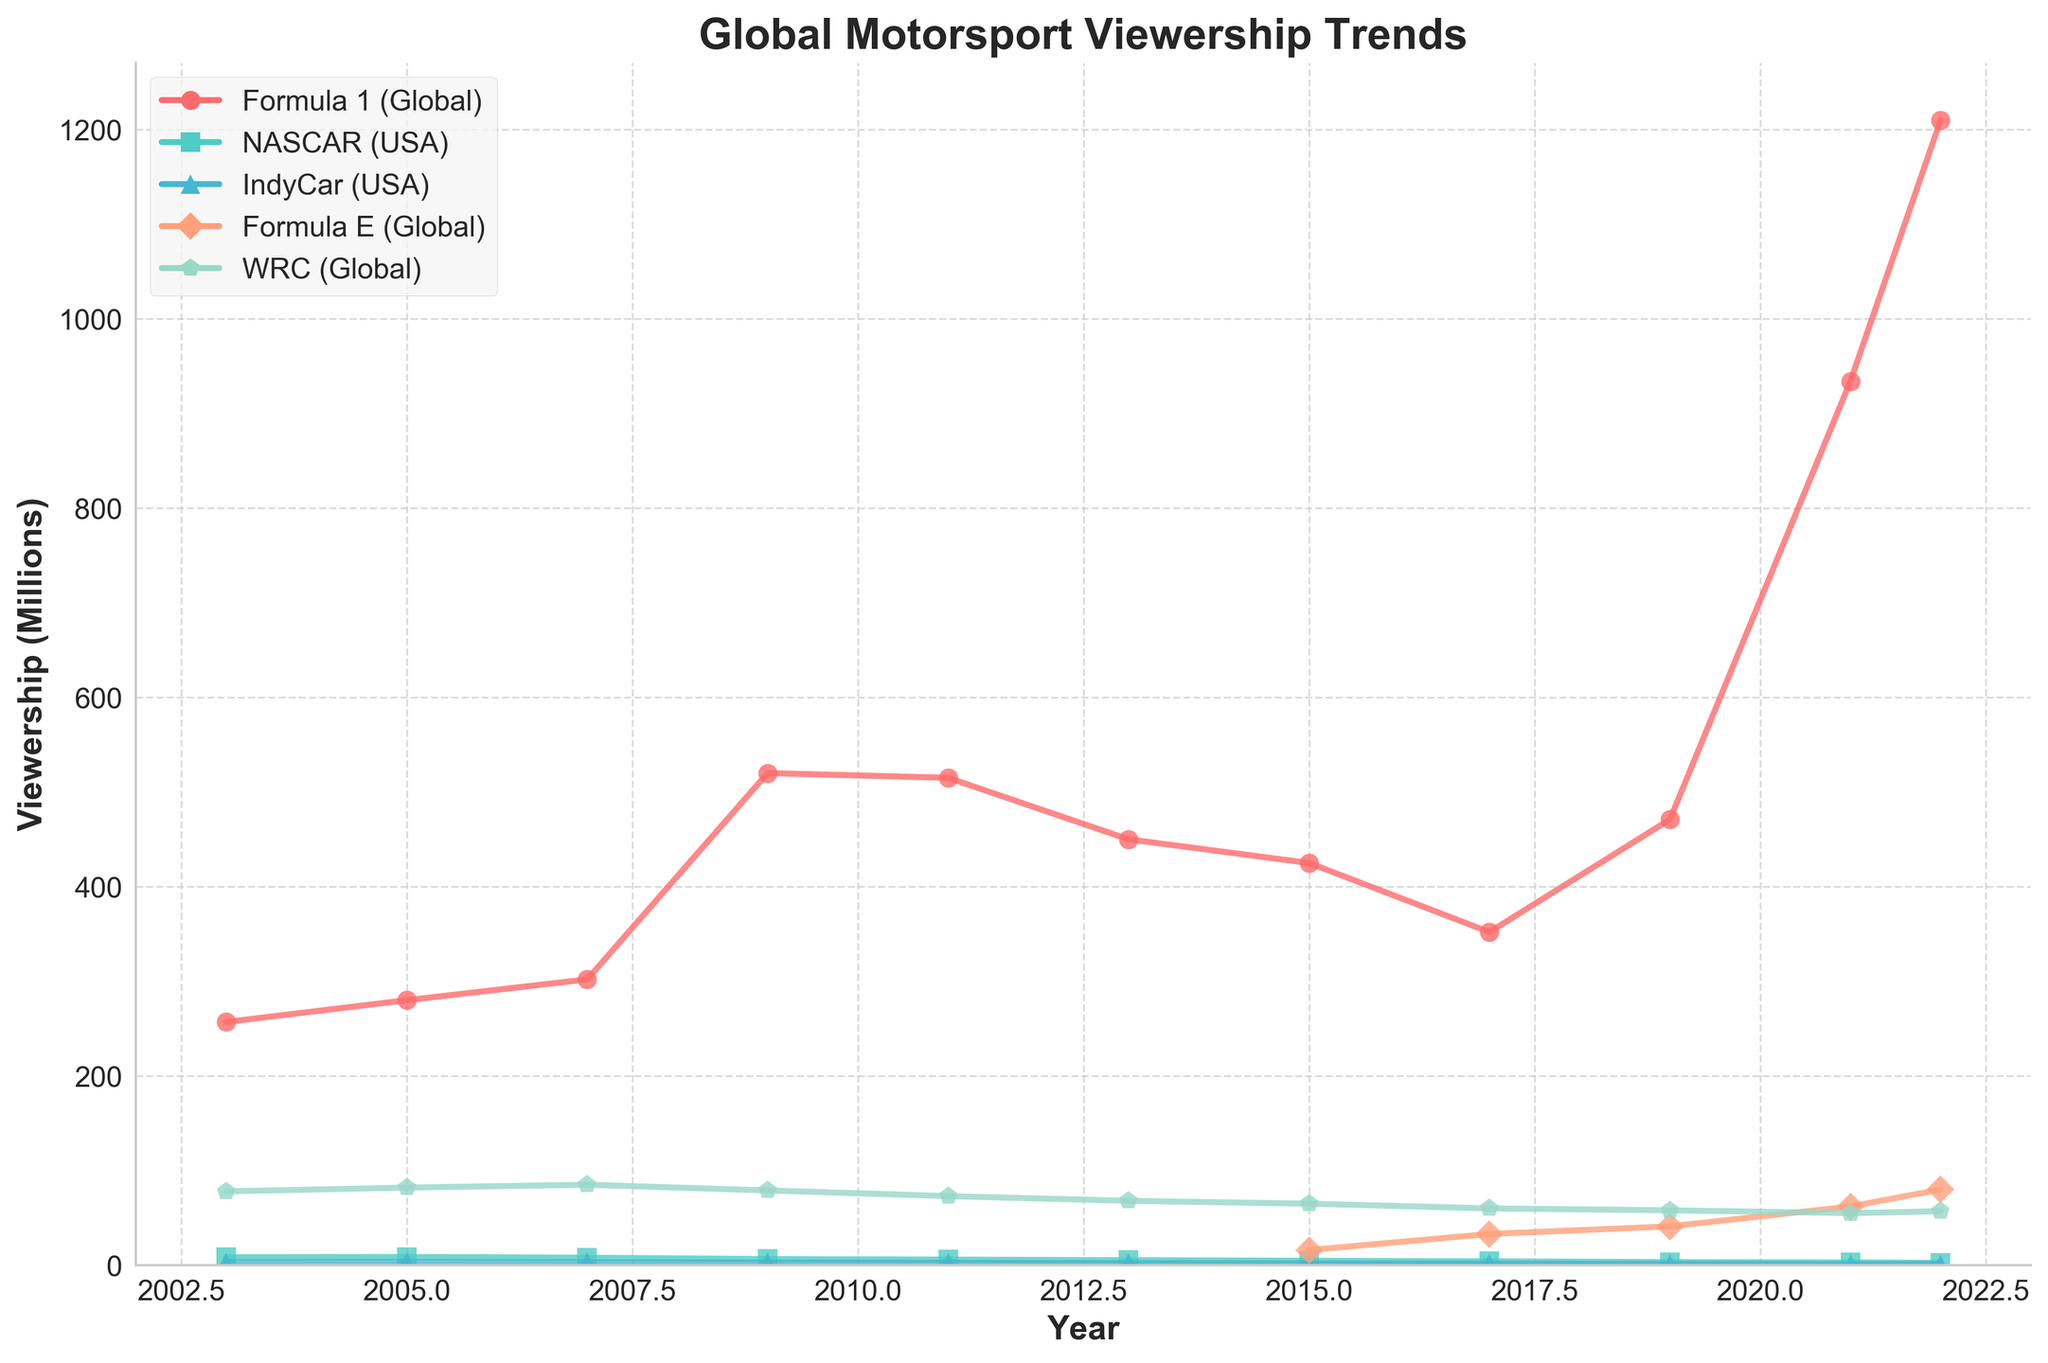What's the trend of Formula 1 viewership over the last 20 years? To determine the trend, observe the line representing Formula 1. The viewership starts at 257 million in 2003, peaks towards 520 million in 2009, drops around 2015 to 425 million, and then surges up sharply to 1210 million by 2022. This shows an initial rise, followed by a decline, and a significant increase in the last few years.
Answer: An initial rise, then decline, followed by a significant increase Which year saw the highest viewership for NASCAR? Look at the NASCAR line and identify the peak point. The highest viewership for NASCAR occurred in 2005 with 8.7 million viewers.
Answer: 2005 Between Formula 1 and NASCAR, which had the higher viewership in 2019? Compare the y-values for Formula 1 and NASCAR in the year 2019. In 2019, Formula 1 had 471 million viewers, whereas NASCAR had 3.3 million. Formula 1 had higher viewership.
Answer: Formula 1 How did the introduction of Formula E in 2015 affect its viewership trend? Observe the start of the Formula E line in 2015 and track its progression. It starts at 16 million in 2015, increases to 33 million by 2017, then rises steadily to 80 million by 2022.
Answer: Steady increase What is the difference in viewership between the highest and lowest points for IndyCar? Identify the peak and the trough for IndyCar. The highest point is 3.5 million in 2005 and the lowest is 1.2 million in 2021. The difference is 3.5 - 1.2 = 2.3 million.
Answer: 2.3 million Which race type had the most stable viewership over these years? To determine stability, look for the line with the least fluctuations. The WRC line shows the least fluctuation, maintaining around 55-85 million throughout the years.
Answer: WRC What was the viewership ratio of Formula 1 to NASCAR in 2011? Find the viewership values for both races in 2011: Formula 1 at 515 million and NASCAR at 5.9 million. The ratio is 515 / 5.9 ≈ 87.3.
Answer: 87.3 Compare the viewership trends of Formula 1 and Formula E from 2015 onward. Identify both trends starting from 2015. Formula 1 starts at 425 million and increases dramatically to 1210 million by 2022, whereas Formula E starts at 16 million and steadily rises to 80 million. Formula 1 has a sharper increase but both show growth.
Answer: Both grow, Formula 1 has a sharper increase What color represents the viewership trend of WRC? Find the WRC line on the chart. It is represented by a green-colored line.
Answer: Green In which year did Formula 1 first exceed 500 million viewers? Track the Formula 1 line and locate the first point exceeding 500 million. It first exceeds 500 million in 2009.
Answer: 2009 